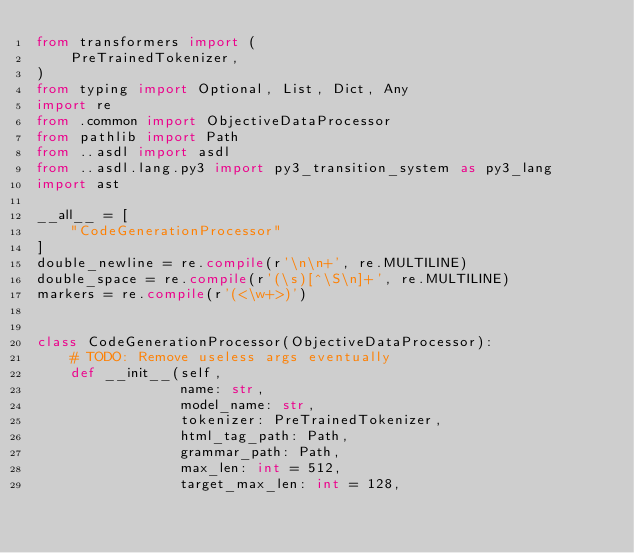Convert code to text. <code><loc_0><loc_0><loc_500><loc_500><_Python_>from transformers import (
    PreTrainedTokenizer,
)
from typing import Optional, List, Dict, Any
import re
from .common import ObjectiveDataProcessor
from pathlib import Path
from ..asdl import asdl
from ..asdl.lang.py3 import py3_transition_system as py3_lang
import ast

__all__ = [
    "CodeGenerationProcessor"
]
double_newline = re.compile(r'\n\n+', re.MULTILINE)
double_space = re.compile(r'(\s)[^\S\n]+', re.MULTILINE)
markers = re.compile(r'(<\w+>)')


class CodeGenerationProcessor(ObjectiveDataProcessor):
    # TODO: Remove useless args eventually
    def __init__(self,
                 name: str,
                 model_name: str,
                 tokenizer: PreTrainedTokenizer,
                 html_tag_path: Path,
                 grammar_path: Path,
                 max_len: int = 512,
                 target_max_len: int = 128,</code> 